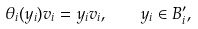Convert formula to latex. <formula><loc_0><loc_0><loc_500><loc_500>\theta _ { i } ( y _ { i } ) v _ { i } = y _ { i } v _ { i } , \quad y _ { i } \in B _ { i } ^ { \prime } ,</formula> 